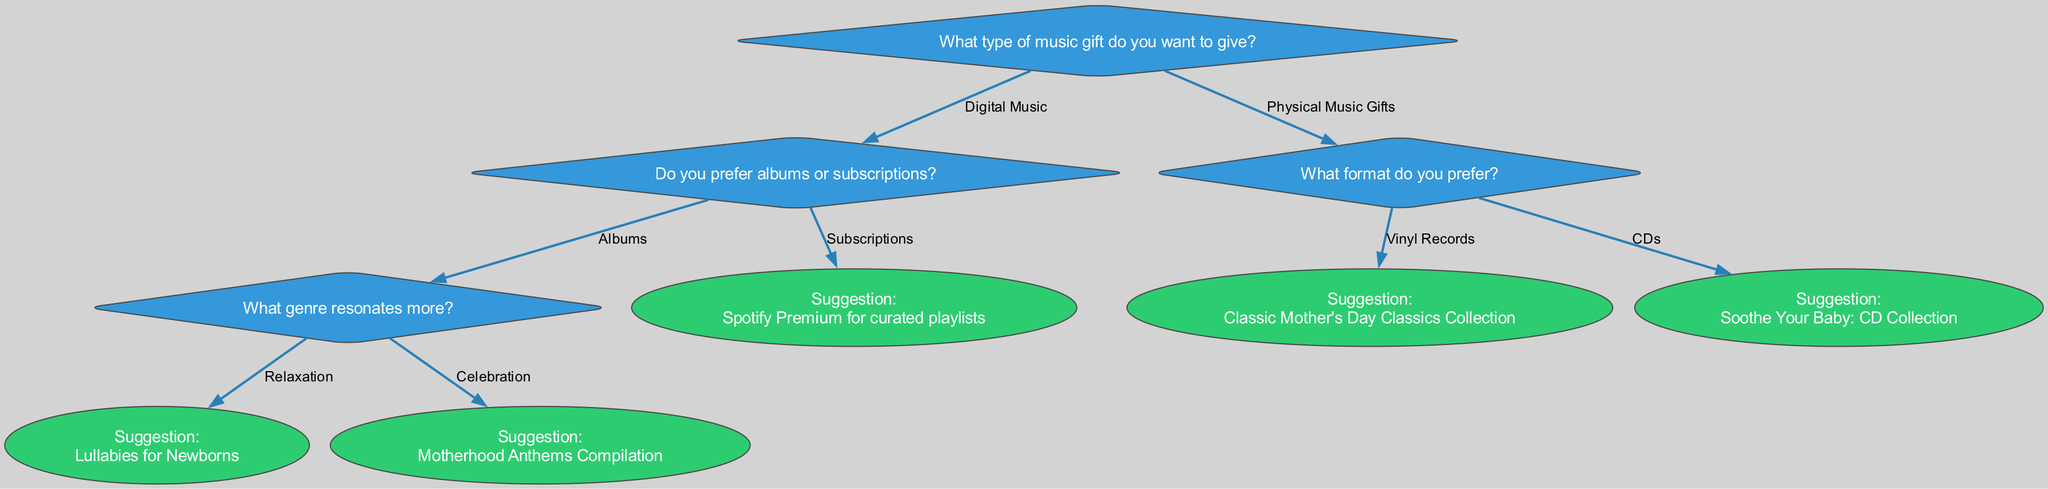What type of music gift can you choose? The diagram begins with a primary question about the type of music gift, which then branches into two main options: Digital Music and Physical Music Gifts.
Answer: Digital Music or Physical Music Gifts What options are available for Digital Music? Under the Digital Music node, there are two subsequent options identified: albums and subscriptions. This determines what type of digital music gift can be selected.
Answer: Albums or Subscriptions What suggestion is linked to the genre Relaxation? Following the selection of Albums, there is a branch that allows for a genre selection. If Relaxation is chosen as the genre, the suggestion provided is "Lullabies for Newborns."
Answer: Lullabies for Newborns How many total suggestions are there in the tree? Counting each suggestion listed in the diagram, there are three distinct suggestions: "Lullabies for Newborns," "Motherhood Anthems Compilation," and "Soothe Your Baby: CD Collection" and "Classic Mother's Day Classics Collection."
Answer: Four Which option would lead to the suggestion "Motherhood Anthems Compilation"? To arrive at the suggestion "Motherhood Anthems Compilation," one must first select Digital Music, then choose Albums, and finally select the genre Celebration. This flow can be traced through the decisions presented in the diagram.
Answer: Celebration under Albums What is the pathway to getting a recommendation for a CD? Starting from the root question, choose Physical Music Gifts, then select the option for CDs. This pathway directly leads to the suggestion "Soothe Your Baby: CD Collection."
Answer: Physical Music Gifts, then CDs What color represents the suggestions in the diagram? The suggestions are visually represented in the diagram with a specific color. Each suggestion node appears in an ellipse shape, and these are filled with a distinct color from others in the diagram.
Answer: Green What is the first question posed in the decision tree? The decision tree begins with the central question, which is the heading that outlines the primary decision point for choosing a gift. This establishes the initial step in the decision-making process.
Answer: What type of music gift do you want to give? 